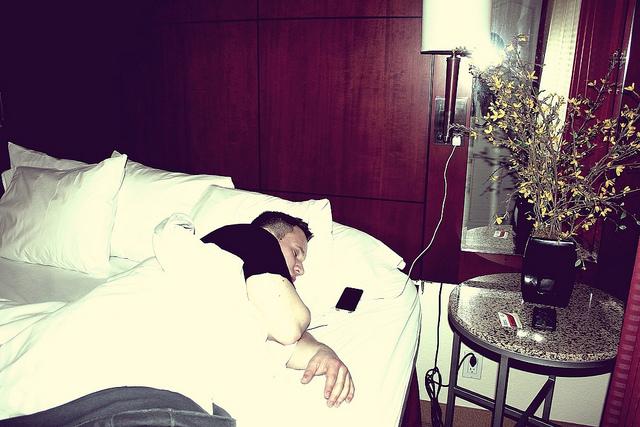What device is plugged in?
Answer briefly. Phone. Is the person a man or a woman?
Keep it brief. Man. Is this man sleeping?
Concise answer only. Yes. Does he have his pajamas on?
Keep it brief. Yes. 